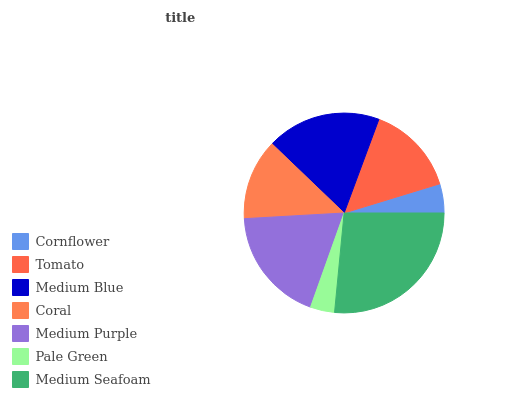Is Pale Green the minimum?
Answer yes or no. Yes. Is Medium Seafoam the maximum?
Answer yes or no. Yes. Is Tomato the minimum?
Answer yes or no. No. Is Tomato the maximum?
Answer yes or no. No. Is Tomato greater than Cornflower?
Answer yes or no. Yes. Is Cornflower less than Tomato?
Answer yes or no. Yes. Is Cornflower greater than Tomato?
Answer yes or no. No. Is Tomato less than Cornflower?
Answer yes or no. No. Is Tomato the high median?
Answer yes or no. Yes. Is Tomato the low median?
Answer yes or no. Yes. Is Medium Blue the high median?
Answer yes or no. No. Is Cornflower the low median?
Answer yes or no. No. 